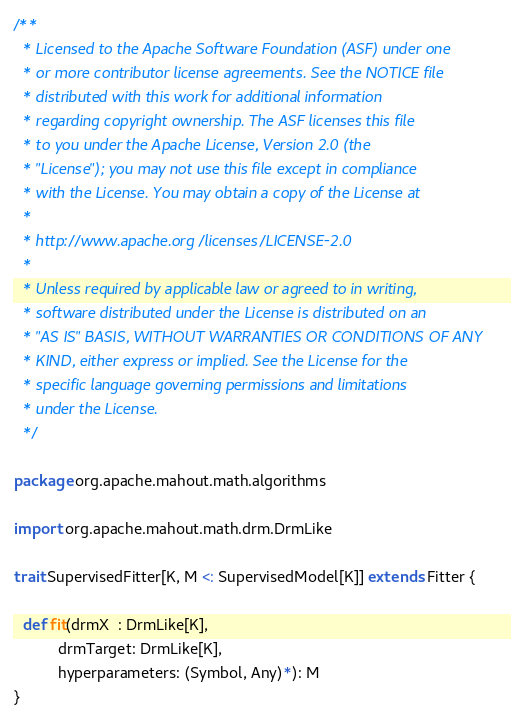Convert code to text. <code><loc_0><loc_0><loc_500><loc_500><_Scala_>/**
  * Licensed to the Apache Software Foundation (ASF) under one
  * or more contributor license agreements. See the NOTICE file
  * distributed with this work for additional information
  * regarding copyright ownership. The ASF licenses this file
  * to you under the Apache License, Version 2.0 (the
  * "License"); you may not use this file except in compliance
  * with the License. You may obtain a copy of the License at
  *
  * http://www.apache.org/licenses/LICENSE-2.0
  *
  * Unless required by applicable law or agreed to in writing,
  * software distributed under the License is distributed on an
  * "AS IS" BASIS, WITHOUT WARRANTIES OR CONDITIONS OF ANY
  * KIND, either express or implied. See the License for the
  * specific language governing permissions and limitations
  * under the License.
  */

package org.apache.mahout.math.algorithms

import org.apache.mahout.math.drm.DrmLike

trait SupervisedFitter[K, M <: SupervisedModel[K]] extends Fitter {

  def fit(drmX  : DrmLike[K],
          drmTarget: DrmLike[K],
          hyperparameters: (Symbol, Any)*): M
}
</code> 